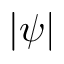Convert formula to latex. <formula><loc_0><loc_0><loc_500><loc_500>| \psi |</formula> 